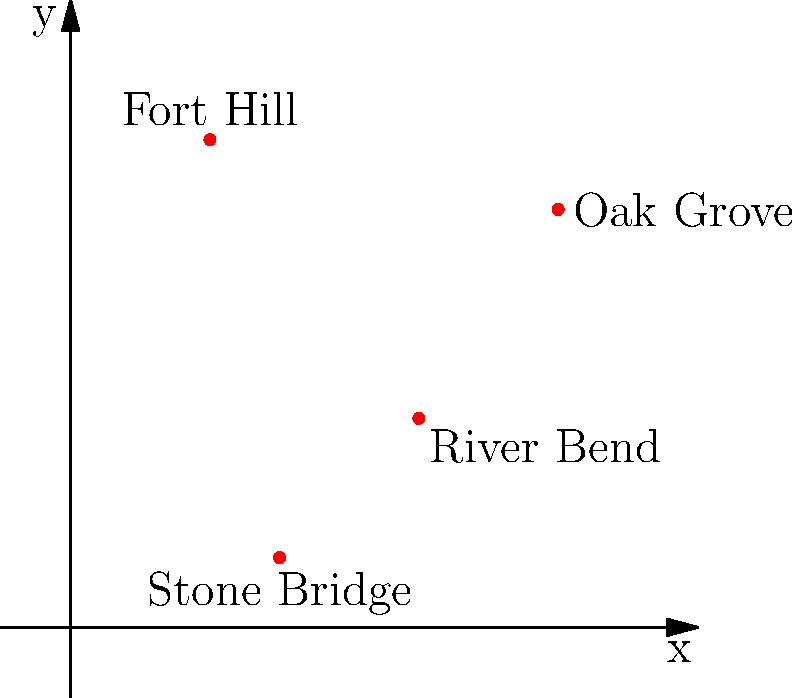According to local legends, four major battle sites from the Great War are located in our area. Their relative positions are shown on the coordinate system above. If a straight line is drawn from Fort Hill to River Bend, which other battle site is closest to this line? To determine which battle site is closest to the line between Fort Hill and River Bend, we need to follow these steps:

1. Identify the coordinates of the battle sites:
   Fort Hill: (2, 7)
   River Bend: (5, 3)
   Oak Grove: (7, 6)
   Stone Bridge: (3, 1)

2. Find the equation of the line passing through Fort Hill and River Bend:
   Using the point-slope form: $y - y_1 = m(x - x_1)$
   Slope $m = \frac{y_2 - y_1}{x_2 - x_1} = \frac{3 - 7}{5 - 2} = -\frac{4}{3}$
   
   Equation: $y - 7 = -\frac{4}{3}(x - 2)$
   Simplified: $y = -\frac{4}{3}x + \frac{31}{3}$

3. Calculate the distance from each remaining point to this line using the formula:
   $d = \frac{|ax_0 + by_0 + c|}{\sqrt{a^2 + b^2}}$, where $ax + by + c = 0$ is the general form of the line equation.

   Rewrite our line equation: $4x + 3y - 31 = 0$

   For Oak Grove (7, 6):
   $d_{OG} = \frac{|4(7) + 3(6) - 31|}{\sqrt{4^2 + 3^2}} = \frac{13}{5} = 2.6$

   For Stone Bridge (3, 1):
   $d_{SB} = \frac{|4(3) + 3(1) - 31|}{\sqrt{4^2 + 3^2}} = \frac{14}{5} = 2.8$

4. Compare the distances:
   Oak Grove: 2.6
   Stone Bridge: 2.8

Therefore, Oak Grove is closer to the line between Fort Hill and River Bend.
Answer: Oak Grove 